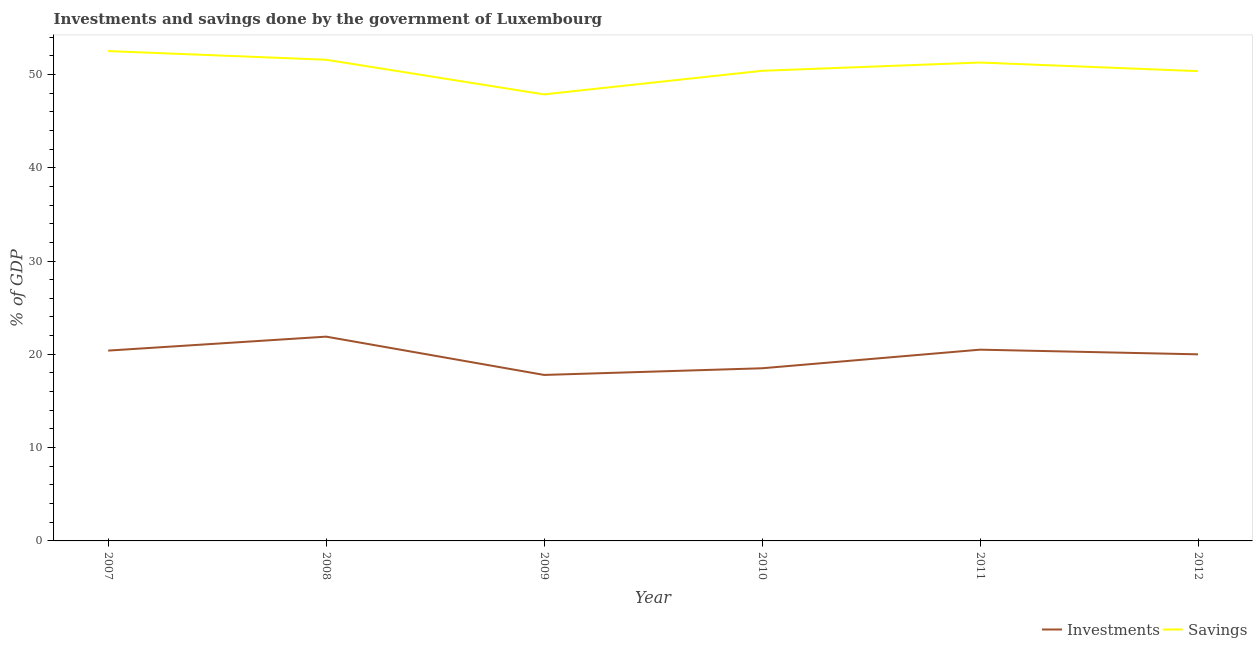What is the investments of government in 2010?
Your answer should be compact. 18.51. Across all years, what is the maximum investments of government?
Ensure brevity in your answer.  21.89. Across all years, what is the minimum savings of government?
Provide a short and direct response. 47.86. What is the total investments of government in the graph?
Provide a short and direct response. 119.08. What is the difference between the investments of government in 2008 and that in 2011?
Offer a terse response. 1.4. What is the difference between the savings of government in 2012 and the investments of government in 2007?
Provide a short and direct response. 29.95. What is the average savings of government per year?
Keep it short and to the point. 50.66. In the year 2010, what is the difference between the investments of government and savings of government?
Your answer should be very brief. -31.88. What is the ratio of the investments of government in 2010 to that in 2012?
Give a very brief answer. 0.93. Is the savings of government in 2010 less than that in 2012?
Your answer should be compact. No. What is the difference between the highest and the second highest savings of government?
Your answer should be very brief. 0.93. What is the difference between the highest and the lowest savings of government?
Your answer should be compact. 4.64. How many years are there in the graph?
Your response must be concise. 6. Does the graph contain grids?
Give a very brief answer. No. How many legend labels are there?
Keep it short and to the point. 2. What is the title of the graph?
Your answer should be very brief. Investments and savings done by the government of Luxembourg. What is the label or title of the Y-axis?
Your response must be concise. % of GDP. What is the % of GDP in Investments in 2007?
Your answer should be very brief. 20.4. What is the % of GDP of Savings in 2007?
Your answer should be very brief. 52.5. What is the % of GDP in Investments in 2008?
Provide a succinct answer. 21.89. What is the % of GDP in Savings in 2008?
Ensure brevity in your answer.  51.57. What is the % of GDP in Investments in 2009?
Give a very brief answer. 17.79. What is the % of GDP of Savings in 2009?
Give a very brief answer. 47.86. What is the % of GDP of Investments in 2010?
Provide a succinct answer. 18.51. What is the % of GDP of Savings in 2010?
Make the answer very short. 50.38. What is the % of GDP in Investments in 2011?
Your answer should be compact. 20.5. What is the % of GDP in Savings in 2011?
Keep it short and to the point. 51.27. What is the % of GDP of Investments in 2012?
Offer a very short reply. 20. What is the % of GDP of Savings in 2012?
Ensure brevity in your answer.  50.35. Across all years, what is the maximum % of GDP in Investments?
Give a very brief answer. 21.89. Across all years, what is the maximum % of GDP in Savings?
Offer a very short reply. 52.5. Across all years, what is the minimum % of GDP of Investments?
Offer a very short reply. 17.79. Across all years, what is the minimum % of GDP of Savings?
Provide a succinct answer. 47.86. What is the total % of GDP of Investments in the graph?
Ensure brevity in your answer.  119.08. What is the total % of GDP of Savings in the graph?
Give a very brief answer. 303.94. What is the difference between the % of GDP in Investments in 2007 and that in 2008?
Your answer should be compact. -1.5. What is the difference between the % of GDP in Savings in 2007 and that in 2008?
Ensure brevity in your answer.  0.93. What is the difference between the % of GDP in Investments in 2007 and that in 2009?
Provide a succinct answer. 2.61. What is the difference between the % of GDP in Savings in 2007 and that in 2009?
Your answer should be very brief. 4.64. What is the difference between the % of GDP of Investments in 2007 and that in 2010?
Give a very brief answer. 1.89. What is the difference between the % of GDP in Savings in 2007 and that in 2010?
Provide a short and direct response. 2.12. What is the difference between the % of GDP of Investments in 2007 and that in 2011?
Your answer should be compact. -0.1. What is the difference between the % of GDP in Savings in 2007 and that in 2011?
Your answer should be very brief. 1.23. What is the difference between the % of GDP in Investments in 2007 and that in 2012?
Keep it short and to the point. 0.4. What is the difference between the % of GDP of Savings in 2007 and that in 2012?
Keep it short and to the point. 2.15. What is the difference between the % of GDP of Investments in 2008 and that in 2009?
Your answer should be very brief. 4.11. What is the difference between the % of GDP in Savings in 2008 and that in 2009?
Your answer should be very brief. 3.72. What is the difference between the % of GDP of Investments in 2008 and that in 2010?
Your response must be concise. 3.39. What is the difference between the % of GDP of Savings in 2008 and that in 2010?
Ensure brevity in your answer.  1.19. What is the difference between the % of GDP of Investments in 2008 and that in 2011?
Provide a short and direct response. 1.4. What is the difference between the % of GDP of Savings in 2008 and that in 2011?
Provide a short and direct response. 0.3. What is the difference between the % of GDP of Investments in 2008 and that in 2012?
Offer a terse response. 1.9. What is the difference between the % of GDP in Savings in 2008 and that in 2012?
Your answer should be very brief. 1.22. What is the difference between the % of GDP in Investments in 2009 and that in 2010?
Your response must be concise. -0.72. What is the difference between the % of GDP of Savings in 2009 and that in 2010?
Provide a succinct answer. -2.53. What is the difference between the % of GDP in Investments in 2009 and that in 2011?
Give a very brief answer. -2.71. What is the difference between the % of GDP in Savings in 2009 and that in 2011?
Provide a succinct answer. -3.41. What is the difference between the % of GDP in Investments in 2009 and that in 2012?
Give a very brief answer. -2.21. What is the difference between the % of GDP of Savings in 2009 and that in 2012?
Make the answer very short. -2.49. What is the difference between the % of GDP in Investments in 2010 and that in 2011?
Your answer should be very brief. -1.99. What is the difference between the % of GDP of Savings in 2010 and that in 2011?
Your answer should be compact. -0.89. What is the difference between the % of GDP in Investments in 2010 and that in 2012?
Offer a very short reply. -1.49. What is the difference between the % of GDP of Savings in 2010 and that in 2012?
Make the answer very short. 0.03. What is the difference between the % of GDP in Investments in 2011 and that in 2012?
Your answer should be compact. 0.5. What is the difference between the % of GDP of Savings in 2011 and that in 2012?
Your answer should be compact. 0.92. What is the difference between the % of GDP of Investments in 2007 and the % of GDP of Savings in 2008?
Keep it short and to the point. -31.18. What is the difference between the % of GDP in Investments in 2007 and the % of GDP in Savings in 2009?
Keep it short and to the point. -27.46. What is the difference between the % of GDP in Investments in 2007 and the % of GDP in Savings in 2010?
Your response must be concise. -29.99. What is the difference between the % of GDP in Investments in 2007 and the % of GDP in Savings in 2011?
Offer a terse response. -30.87. What is the difference between the % of GDP in Investments in 2007 and the % of GDP in Savings in 2012?
Offer a very short reply. -29.95. What is the difference between the % of GDP in Investments in 2008 and the % of GDP in Savings in 2009?
Keep it short and to the point. -25.96. What is the difference between the % of GDP of Investments in 2008 and the % of GDP of Savings in 2010?
Provide a short and direct response. -28.49. What is the difference between the % of GDP in Investments in 2008 and the % of GDP in Savings in 2011?
Make the answer very short. -29.38. What is the difference between the % of GDP in Investments in 2008 and the % of GDP in Savings in 2012?
Provide a succinct answer. -28.46. What is the difference between the % of GDP of Investments in 2009 and the % of GDP of Savings in 2010?
Offer a terse response. -32.6. What is the difference between the % of GDP of Investments in 2009 and the % of GDP of Savings in 2011?
Your answer should be very brief. -33.48. What is the difference between the % of GDP of Investments in 2009 and the % of GDP of Savings in 2012?
Your response must be concise. -32.56. What is the difference between the % of GDP of Investments in 2010 and the % of GDP of Savings in 2011?
Keep it short and to the point. -32.77. What is the difference between the % of GDP of Investments in 2010 and the % of GDP of Savings in 2012?
Offer a very short reply. -31.85. What is the difference between the % of GDP in Investments in 2011 and the % of GDP in Savings in 2012?
Your answer should be compact. -29.85. What is the average % of GDP in Investments per year?
Offer a very short reply. 19.85. What is the average % of GDP in Savings per year?
Provide a short and direct response. 50.66. In the year 2007, what is the difference between the % of GDP of Investments and % of GDP of Savings?
Give a very brief answer. -32.1. In the year 2008, what is the difference between the % of GDP in Investments and % of GDP in Savings?
Provide a succinct answer. -29.68. In the year 2009, what is the difference between the % of GDP in Investments and % of GDP in Savings?
Make the answer very short. -30.07. In the year 2010, what is the difference between the % of GDP of Investments and % of GDP of Savings?
Your response must be concise. -31.88. In the year 2011, what is the difference between the % of GDP in Investments and % of GDP in Savings?
Give a very brief answer. -30.77. In the year 2012, what is the difference between the % of GDP in Investments and % of GDP in Savings?
Offer a terse response. -30.35. What is the ratio of the % of GDP in Investments in 2007 to that in 2008?
Your response must be concise. 0.93. What is the ratio of the % of GDP of Investments in 2007 to that in 2009?
Ensure brevity in your answer.  1.15. What is the ratio of the % of GDP of Savings in 2007 to that in 2009?
Offer a very short reply. 1.1. What is the ratio of the % of GDP of Investments in 2007 to that in 2010?
Provide a short and direct response. 1.1. What is the ratio of the % of GDP of Savings in 2007 to that in 2010?
Offer a terse response. 1.04. What is the ratio of the % of GDP in Savings in 2007 to that in 2011?
Ensure brevity in your answer.  1.02. What is the ratio of the % of GDP of Savings in 2007 to that in 2012?
Provide a short and direct response. 1.04. What is the ratio of the % of GDP in Investments in 2008 to that in 2009?
Offer a terse response. 1.23. What is the ratio of the % of GDP in Savings in 2008 to that in 2009?
Make the answer very short. 1.08. What is the ratio of the % of GDP in Investments in 2008 to that in 2010?
Provide a succinct answer. 1.18. What is the ratio of the % of GDP in Savings in 2008 to that in 2010?
Give a very brief answer. 1.02. What is the ratio of the % of GDP of Investments in 2008 to that in 2011?
Your answer should be very brief. 1.07. What is the ratio of the % of GDP in Savings in 2008 to that in 2011?
Make the answer very short. 1.01. What is the ratio of the % of GDP in Investments in 2008 to that in 2012?
Keep it short and to the point. 1.09. What is the ratio of the % of GDP in Savings in 2008 to that in 2012?
Offer a very short reply. 1.02. What is the ratio of the % of GDP in Investments in 2009 to that in 2010?
Give a very brief answer. 0.96. What is the ratio of the % of GDP of Savings in 2009 to that in 2010?
Keep it short and to the point. 0.95. What is the ratio of the % of GDP of Investments in 2009 to that in 2011?
Make the answer very short. 0.87. What is the ratio of the % of GDP of Savings in 2009 to that in 2011?
Provide a short and direct response. 0.93. What is the ratio of the % of GDP in Investments in 2009 to that in 2012?
Provide a short and direct response. 0.89. What is the ratio of the % of GDP in Savings in 2009 to that in 2012?
Your answer should be very brief. 0.95. What is the ratio of the % of GDP of Investments in 2010 to that in 2011?
Make the answer very short. 0.9. What is the ratio of the % of GDP of Savings in 2010 to that in 2011?
Provide a short and direct response. 0.98. What is the ratio of the % of GDP in Investments in 2010 to that in 2012?
Provide a succinct answer. 0.93. What is the ratio of the % of GDP of Savings in 2011 to that in 2012?
Your response must be concise. 1.02. What is the difference between the highest and the second highest % of GDP of Investments?
Keep it short and to the point. 1.4. What is the difference between the highest and the second highest % of GDP of Savings?
Your answer should be very brief. 0.93. What is the difference between the highest and the lowest % of GDP in Investments?
Keep it short and to the point. 4.11. What is the difference between the highest and the lowest % of GDP in Savings?
Keep it short and to the point. 4.64. 